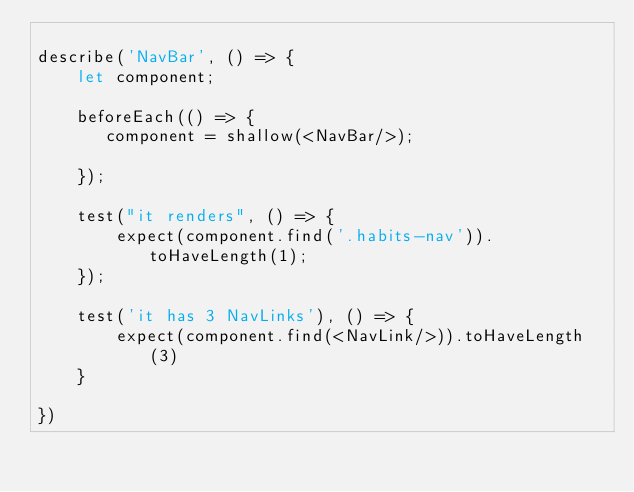<code> <loc_0><loc_0><loc_500><loc_500><_JavaScript_>
describe('NavBar', () => {
    let component;

    beforeEach(() => {
       component = shallow(<NavBar/>);

    });

    test("it renders", () => {
        expect(component.find('.habits-nav')).toHaveLength(1);
    });

    test('it has 3 NavLinks'), () => {
        expect(component.find(<NavLink/>)).toHaveLength(3)
    }

})</code> 